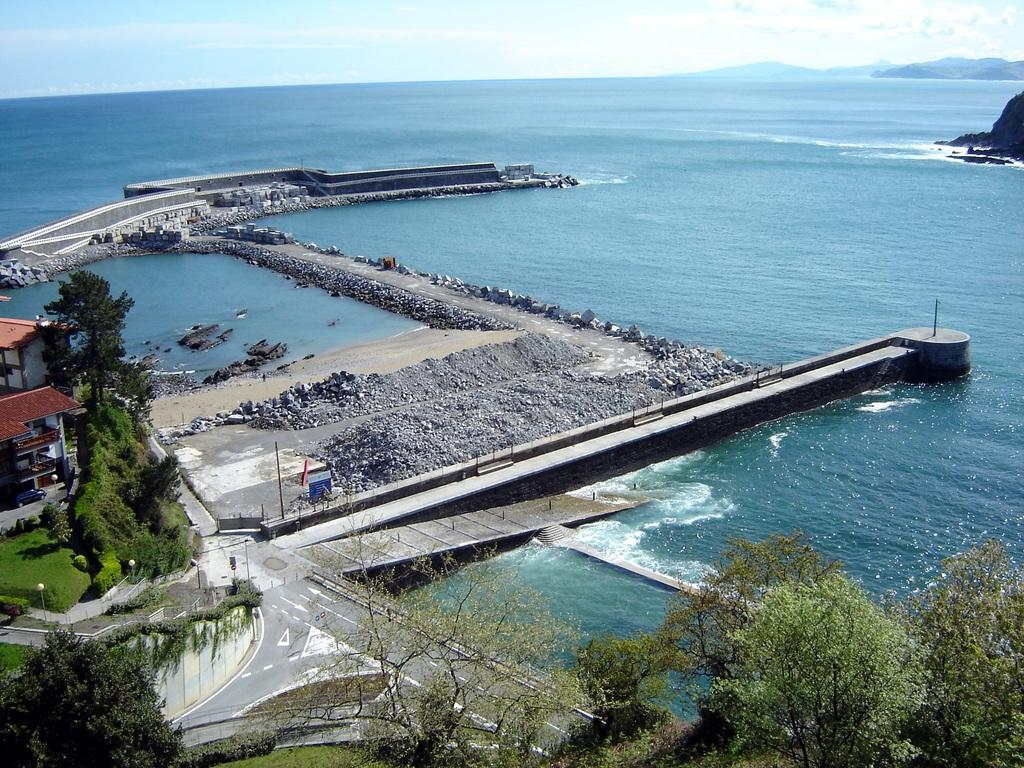What is located on the left side of the image? There are buildings, trees, and a grass lawn on the left side of the image. What type of transportation infrastructure can be seen in the image? There are roads in the image. What other natural elements are present in the image besides the grass lawn? There are trees and rocks in the image. What can be seen in the back of the image? Water and the sky are visible in the back of the image. Can you see any steam coming from the buildings in the image? There is no steam visible in the image; it only shows buildings, trees, a grass lawn, roads, trees, rocks, water, and the sky. Are there any flames visible in the image? There are no flames present in the image. 